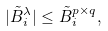<formula> <loc_0><loc_0><loc_500><loc_500>| \tilde { B } ^ { \lambda } _ { i } | \leq \tilde { B } ^ { p \times q } _ { i } ,</formula> 